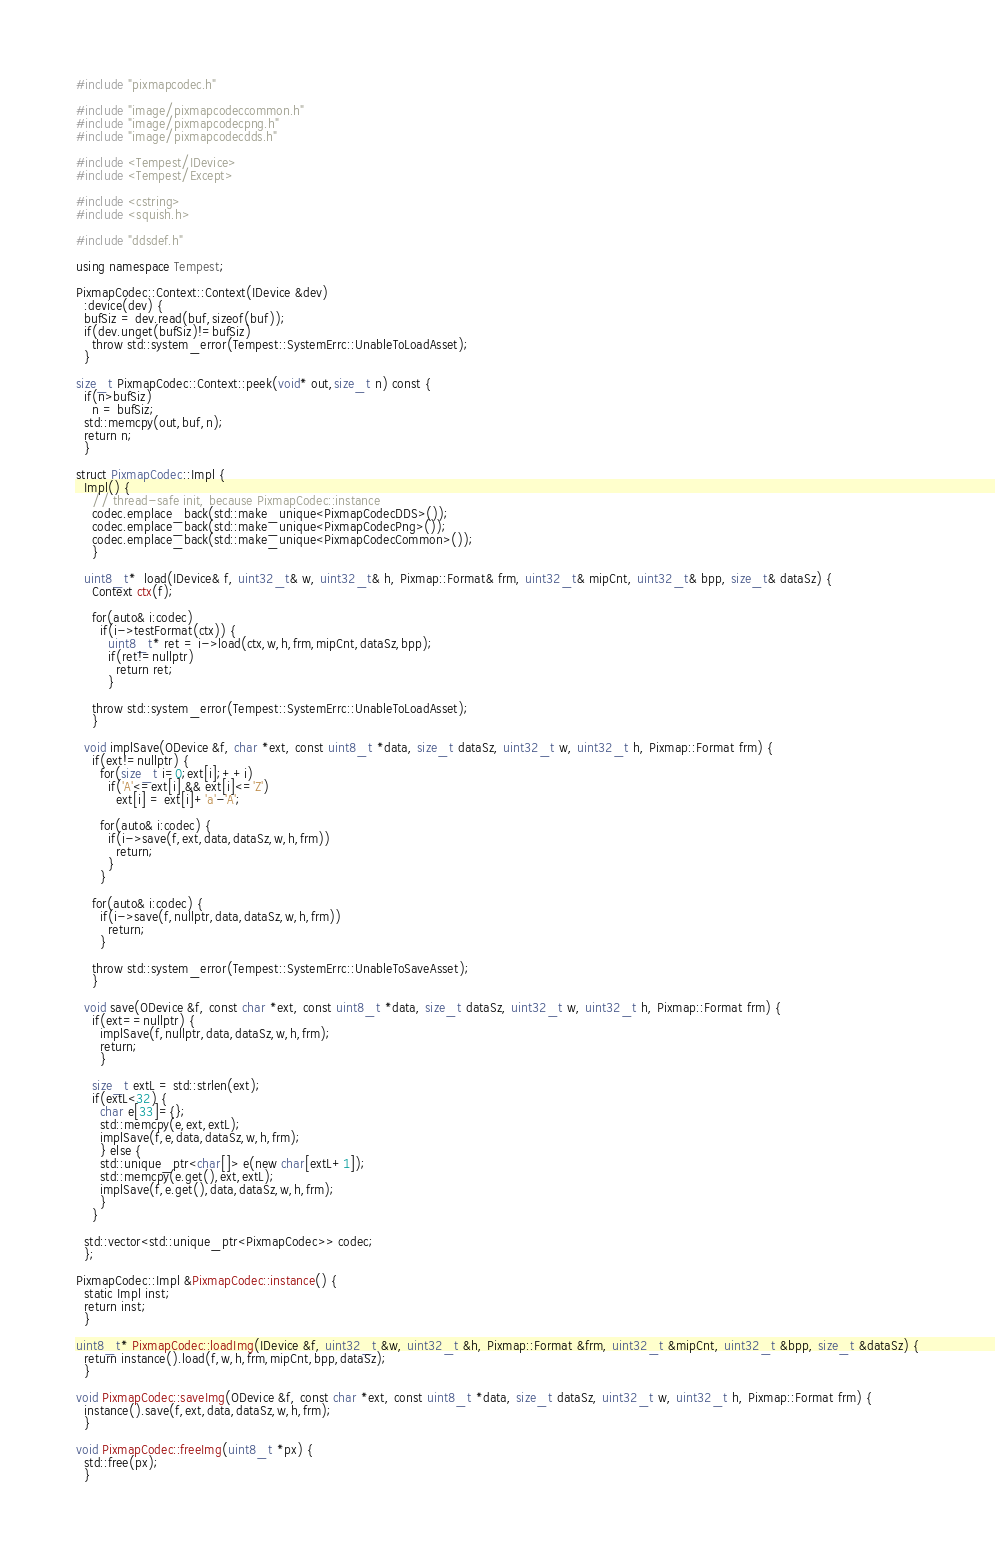Convert code to text. <code><loc_0><loc_0><loc_500><loc_500><_C++_>#include "pixmapcodec.h"

#include "image/pixmapcodeccommon.h"
#include "image/pixmapcodecpng.h"
#include "image/pixmapcodecdds.h"

#include <Tempest/IDevice>
#include <Tempest/Except>

#include <cstring>
#include <squish.h>

#include "ddsdef.h"

using namespace Tempest;

PixmapCodec::Context::Context(IDevice &dev)
  :device(dev) {
  bufSiz = dev.read(buf,sizeof(buf));
  if(dev.unget(bufSiz)!=bufSiz)
    throw std::system_error(Tempest::SystemErrc::UnableToLoadAsset);
  }

size_t PixmapCodec::Context::peek(void* out,size_t n) const {
  if(n>bufSiz)
    n = bufSiz;
  std::memcpy(out,buf,n);
  return n;
  }

struct PixmapCodec::Impl {
  Impl() {
    // thread-safe init, because PixmapCodec::instance
    codec.emplace_back(std::make_unique<PixmapCodecDDS>());
    codec.emplace_back(std::make_unique<PixmapCodecPng>());
    codec.emplace_back(std::make_unique<PixmapCodecCommon>());
    }

  uint8_t*  load(IDevice& f, uint32_t& w, uint32_t& h, Pixmap::Format& frm, uint32_t& mipCnt, uint32_t& bpp, size_t& dataSz) {
    Context ctx(f);

    for(auto& i:codec)
      if(i->testFormat(ctx)) {
        uint8_t* ret = i->load(ctx,w,h,frm,mipCnt,dataSz,bpp);
        if(ret!=nullptr)
          return ret;
        }

    throw std::system_error(Tempest::SystemErrc::UnableToLoadAsset);
    }

  void implSave(ODevice &f, char *ext, const uint8_t *data, size_t dataSz, uint32_t w, uint32_t h, Pixmap::Format frm) {
    if(ext!=nullptr) {
      for(size_t i=0;ext[i];++i)
        if('A'<=ext[i] && ext[i]<='Z')
          ext[i] = ext[i]+'a'-'A';

      for(auto& i:codec) {
        if(i->save(f,ext,data,dataSz,w,h,frm))
          return;
        }
      }

    for(auto& i:codec) {
      if(i->save(f,nullptr,data,dataSz,w,h,frm))
        return;
      }

    throw std::system_error(Tempest::SystemErrc::UnableToSaveAsset);
    }

  void save(ODevice &f, const char *ext, const uint8_t *data, size_t dataSz, uint32_t w, uint32_t h, Pixmap::Format frm) {
    if(ext==nullptr) {
      implSave(f,nullptr,data,dataSz,w,h,frm);
      return;
      }

    size_t extL = std::strlen(ext);
    if(extL<32) {
      char e[33]={};
      std::memcpy(e,ext,extL);
      implSave(f,e,data,dataSz,w,h,frm);
      } else {
      std::unique_ptr<char[]> e(new char[extL+1]);
      std::memcpy(e.get(),ext,extL);
      implSave(f,e.get(),data,dataSz,w,h,frm);
      }
    }

  std::vector<std::unique_ptr<PixmapCodec>> codec;
  };

PixmapCodec::Impl &PixmapCodec::instance() {
  static Impl inst;
  return inst;
  }

uint8_t* PixmapCodec::loadImg(IDevice &f, uint32_t &w, uint32_t &h, Pixmap::Format &frm, uint32_t &mipCnt, uint32_t &bpp, size_t &dataSz) {
  return instance().load(f,w,h,frm,mipCnt,bpp,dataSz);
  }

void PixmapCodec::saveImg(ODevice &f, const char *ext, const uint8_t *data, size_t dataSz, uint32_t w, uint32_t h, Pixmap::Format frm) {
  instance().save(f,ext,data,dataSz,w,h,frm);
  }

void PixmapCodec::freeImg(uint8_t *px) {
  std::free(px);
  }
</code> 